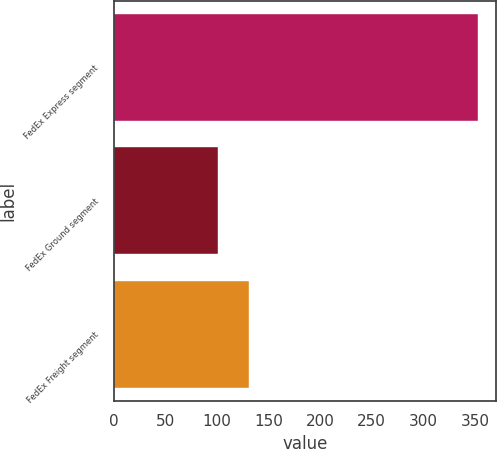<chart> <loc_0><loc_0><loc_500><loc_500><bar_chart><fcel>FedEx Express segment<fcel>FedEx Ground segment<fcel>FedEx Freight segment<nl><fcel>353<fcel>101<fcel>131<nl></chart> 